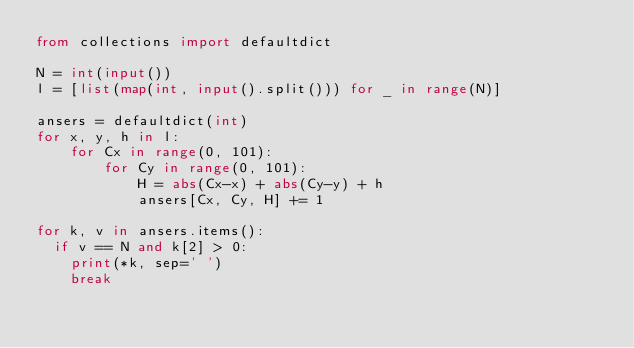Convert code to text. <code><loc_0><loc_0><loc_500><loc_500><_Python_>from collections import defaultdict

N = int(input())
l = [list(map(int, input().split())) for _ in range(N)]

ansers = defaultdict(int)
for x, y, h in l:
    for Cx in range(0, 101):
        for Cy in range(0, 101):
            H = abs(Cx-x) + abs(Cy-y) + h
            ansers[Cx, Cy, H] += 1
            
for k, v in ansers.items():
  if v == N and k[2] > 0:
    print(*k, sep=' ')
    break
</code> 